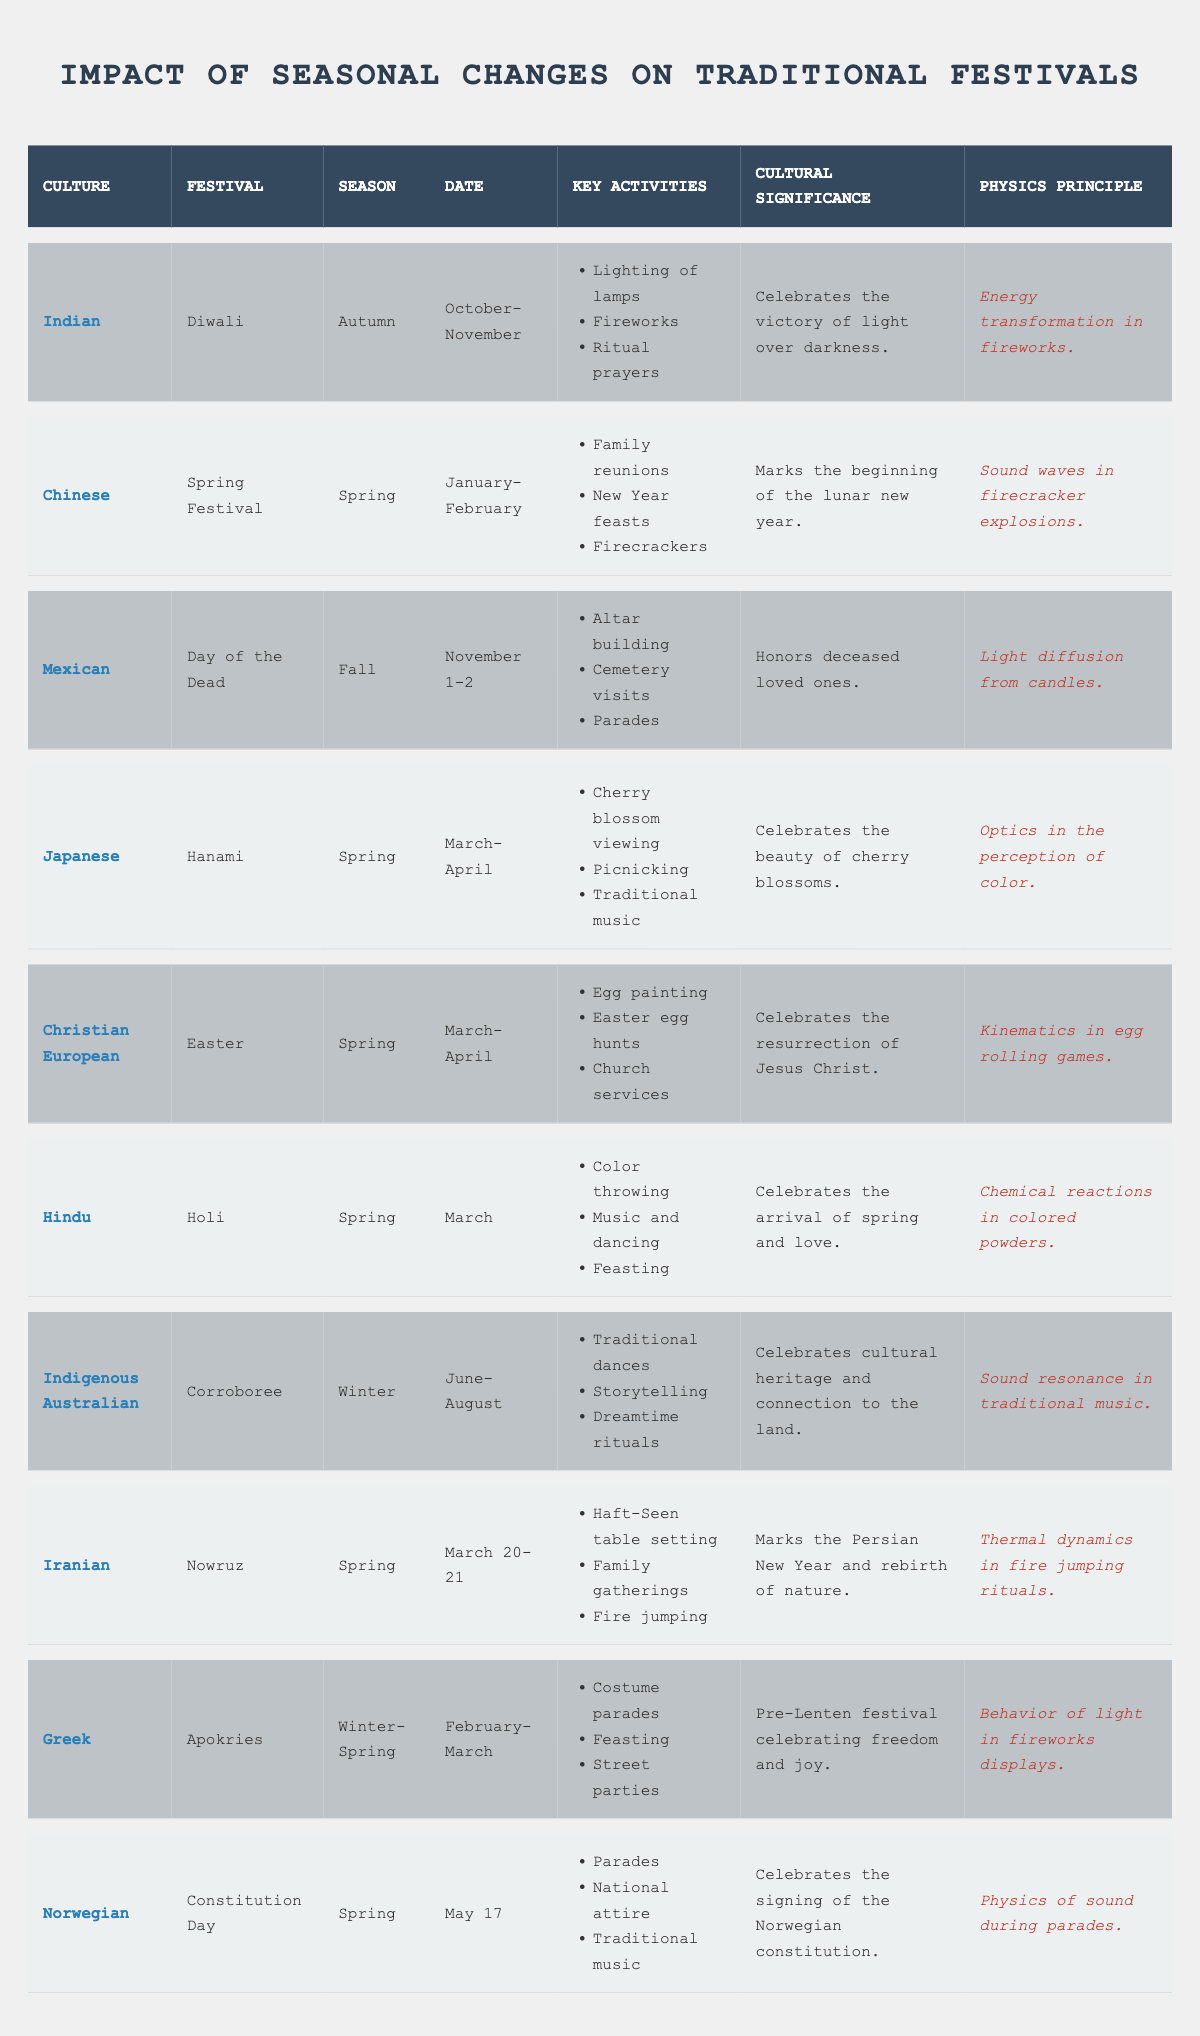What culture celebrates Diwali? The table lists the festival Diwali under the Indian culture.
Answer: Indian During which season is the Day of the Dead celebrated? The table states that the Day of the Dead festival occurs in the Fall season.
Answer: Fall What are the key activities of the Spring Festival? The key activities include family reunions, New Year feasts, and firecrackers, which can be found in the details for the Spring Festival.
Answer: Family reunions, New Year feasts, firecrackers Are there any festivals listed that celebrate the arrival of spring? Yes, the table shows that Holi, Nowruz, and Easter are associated with the arrival of spring.
Answer: Yes Which festival has a cultural significance related to honoring deceased loved ones? The table indicates that the Day of the Dead honors deceased loved ones, found in its cultural significance.
Answer: Day of the Dead Count how many festivals are celebrated in Spring. Looking through the table, the festivals celebrated in Spring are Spring Festival, Hanami, Easter, Holi, and Nowruz, totaling 5 festivals.
Answer: 5 What physics principle is associated with firework displays in the Greek festival? The table notes that the physics principle related to firework displays is "Behavior of light in fireworks displays" for the Apokries festival.
Answer: Behavior of light in fireworks displays Is the celebration of Nowruz specific to any one culture? Yes, the table denotes that Nowruz is specifically linked to Iranian culture.
Answer: Yes How do the key activities of Holi relate to the arrival of spring? Holi's key activities, like color throwing and feasting, symbolize the joy and vibrant colors associated with spring, emphasizing its themes of renewal and love.
Answer: Celebrates renewal and love Which festival occurs on March 20-21 and what is its cultural significance? Nowruz occurs on March 20-21, celebrating the Persian New Year and the rebirth of nature, as indicated in the table.
Answer: Nowruz; marks the Persian New Year and rebirth of nature 